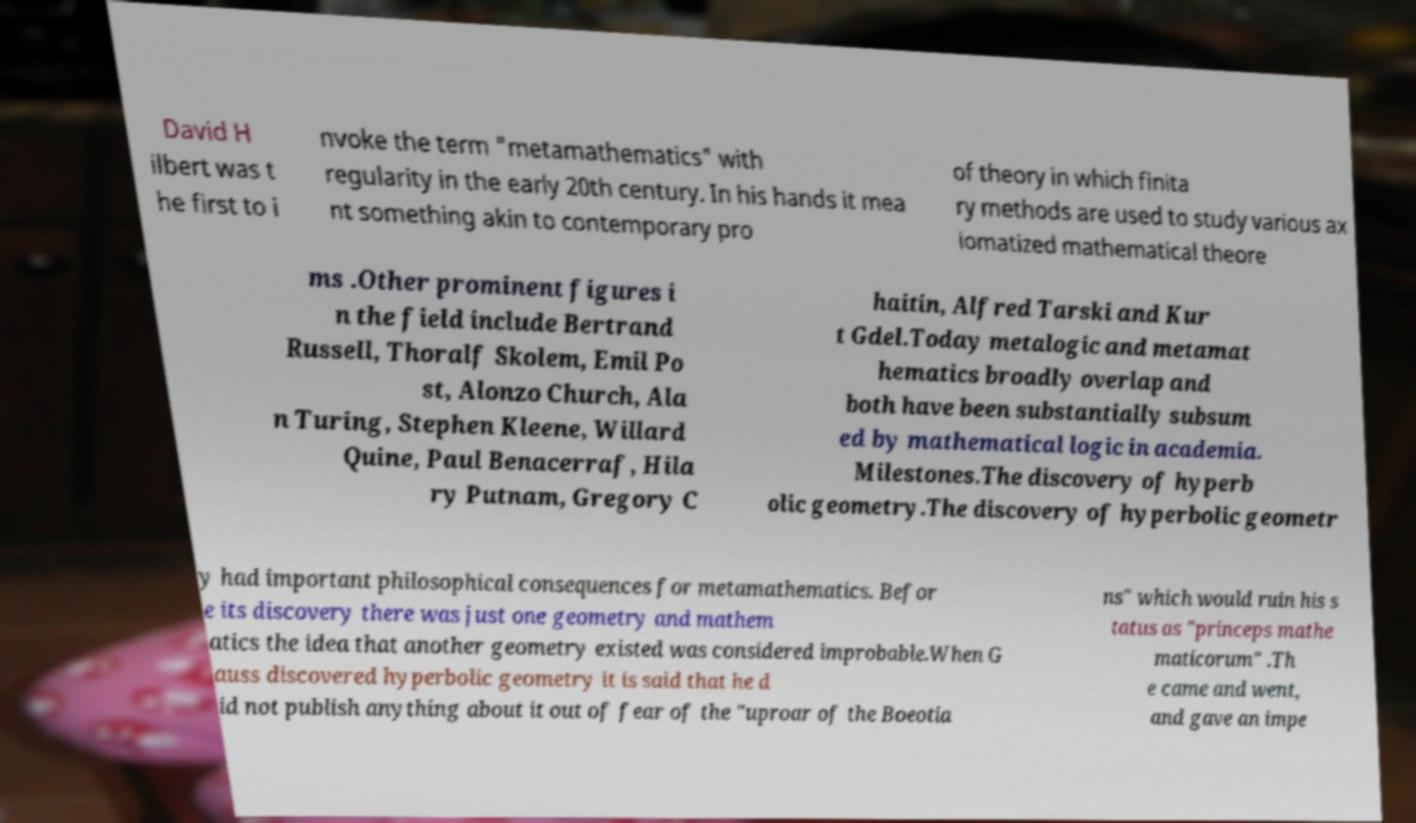For documentation purposes, I need the text within this image transcribed. Could you provide that? David H ilbert was t he first to i nvoke the term "metamathematics" with regularity in the early 20th century. In his hands it mea nt something akin to contemporary pro of theory in which finita ry methods are used to study various ax iomatized mathematical theore ms .Other prominent figures i n the field include Bertrand Russell, Thoralf Skolem, Emil Po st, Alonzo Church, Ala n Turing, Stephen Kleene, Willard Quine, Paul Benacerraf, Hila ry Putnam, Gregory C haitin, Alfred Tarski and Kur t Gdel.Today metalogic and metamat hematics broadly overlap and both have been substantially subsum ed by mathematical logic in academia. Milestones.The discovery of hyperb olic geometry.The discovery of hyperbolic geometr y had important philosophical consequences for metamathematics. Befor e its discovery there was just one geometry and mathem atics the idea that another geometry existed was considered improbable.When G auss discovered hyperbolic geometry it is said that he d id not publish anything about it out of fear of the "uproar of the Boeotia ns" which would ruin his s tatus as "princeps mathe maticorum" .Th e came and went, and gave an impe 